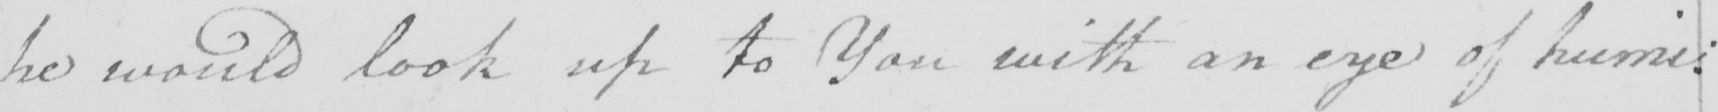Please transcribe the handwritten text in this image. he would look up to You with an eye of humi= 